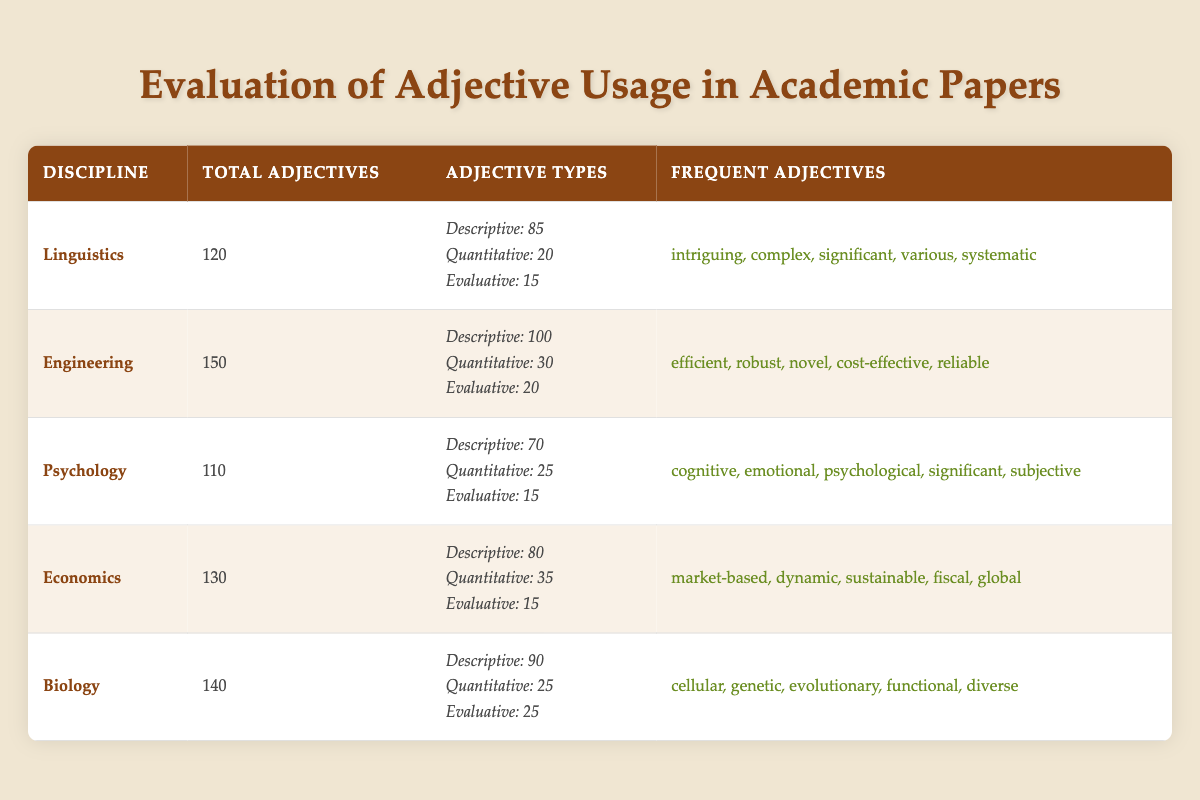What is the total number of adjectives used in Linguistics? The table indicates that the total adjectives used in Linguistics are listed as 120.
Answer: 120 Which discipline has the highest number of total adjectives? By comparing the total adjectives across all disciplines, Engineering has 150, which is the highest number.
Answer: Engineering How many evaluative adjectives are used in Biology? The table shows that Biology has 25 evaluative adjectives listed under its adjective types.
Answer: 25 What is the average number of descriptive adjectives across all disciplines? Summing the descriptive adjectives (85 + 100 + 70 + 80 + 90) equals 425. There are 5 disciplines, so the average is 425/5 = 85.
Answer: 85 Does Psychology have more quantitative adjectives than Linguistics? Psychology has 25 quantitative adjectives while Linguistics has 20. Since 25 is greater than 20, the statement is true.
Answer: Yes Which discipline uses the adjective "significant" most frequently? The table mentions "significant" as a frequent adjective in both Linguistics and Psychology, meaning it is equally frequent in both.
Answer: Linguistics and Psychology What is the total number of descriptive adjectives used in the disciplines of Engineering and Economics combined? Adding the descriptive adjectives from both disciplines gives 100 (Engineering) + 80 (Economics) = 180.
Answer: 180 Are there any disciplines that use more than 100 total adjectives? Looking at the total adjectives, both Engineering (150) and Biology (140) exceed 100. Therefore, the statement is true.
Answer: Yes If you combine all the evaluative adjectives from the five disciplines, what is the total? The total of evaluative adjectives is calculated as 15 (Linguistics) + 20 (Engineering) + 15 (Psychology) + 15 (Economics) + 25 (Biology) = 90.
Answer: 90 Which discipline has the least number of frequent adjectives? By looking at the provided frequent adjectives, both Linguistics and Psychology have 5 frequent adjectives each. Hence, none has fewer than that.
Answer: None 